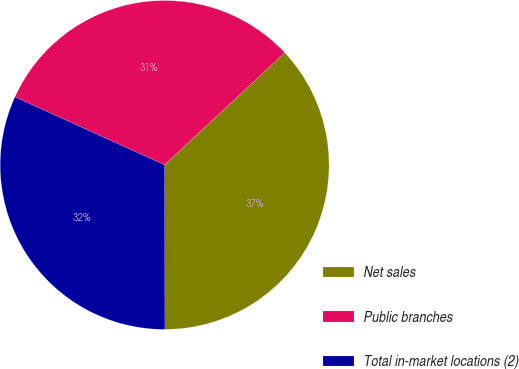Convert chart. <chart><loc_0><loc_0><loc_500><loc_500><pie_chart><fcel>Net sales<fcel>Public branches<fcel>Total in-market locations (2)<nl><fcel>36.93%<fcel>31.25%<fcel>31.82%<nl></chart> 